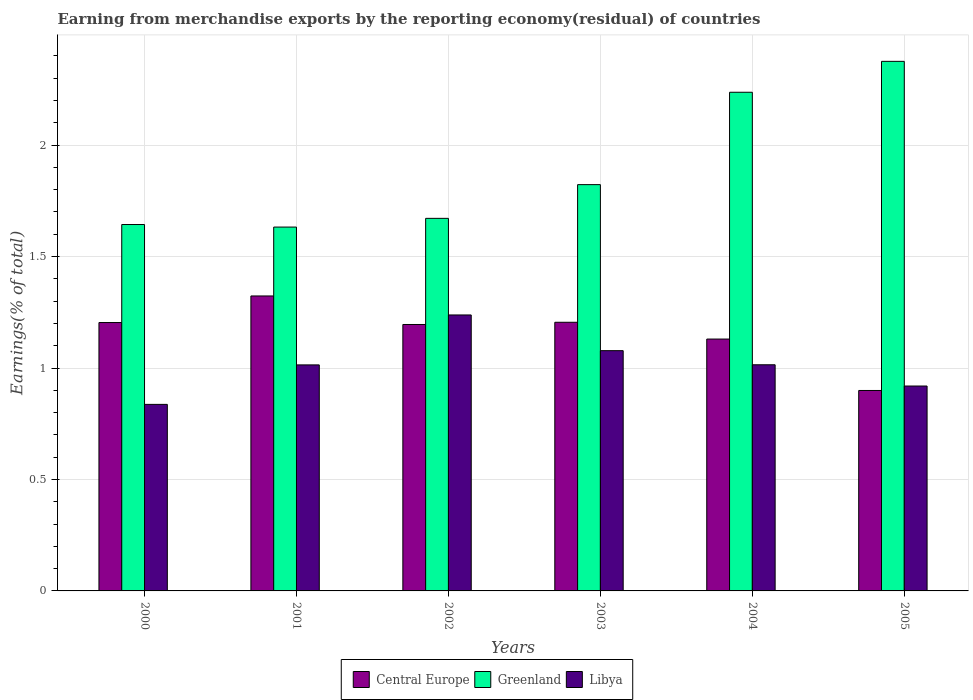Are the number of bars per tick equal to the number of legend labels?
Your answer should be very brief. Yes. How many bars are there on the 3rd tick from the left?
Your answer should be compact. 3. What is the label of the 1st group of bars from the left?
Provide a succinct answer. 2000. In how many cases, is the number of bars for a given year not equal to the number of legend labels?
Ensure brevity in your answer.  0. What is the percentage of amount earned from merchandise exports in Libya in 2005?
Provide a short and direct response. 0.92. Across all years, what is the maximum percentage of amount earned from merchandise exports in Greenland?
Ensure brevity in your answer.  2.38. Across all years, what is the minimum percentage of amount earned from merchandise exports in Libya?
Your answer should be compact. 0.84. What is the total percentage of amount earned from merchandise exports in Central Europe in the graph?
Provide a succinct answer. 6.96. What is the difference between the percentage of amount earned from merchandise exports in Greenland in 2000 and that in 2004?
Your answer should be compact. -0.59. What is the difference between the percentage of amount earned from merchandise exports in Central Europe in 2005 and the percentage of amount earned from merchandise exports in Libya in 2001?
Your answer should be compact. -0.11. What is the average percentage of amount earned from merchandise exports in Central Europe per year?
Provide a short and direct response. 1.16. In the year 2005, what is the difference between the percentage of amount earned from merchandise exports in Greenland and percentage of amount earned from merchandise exports in Libya?
Provide a succinct answer. 1.46. In how many years, is the percentage of amount earned from merchandise exports in Libya greater than 0.30000000000000004 %?
Keep it short and to the point. 6. What is the ratio of the percentage of amount earned from merchandise exports in Central Europe in 2000 to that in 2002?
Offer a terse response. 1.01. Is the percentage of amount earned from merchandise exports in Central Europe in 2000 less than that in 2005?
Offer a very short reply. No. Is the difference between the percentage of amount earned from merchandise exports in Greenland in 2003 and 2004 greater than the difference between the percentage of amount earned from merchandise exports in Libya in 2003 and 2004?
Offer a terse response. No. What is the difference between the highest and the second highest percentage of amount earned from merchandise exports in Greenland?
Your response must be concise. 0.14. What is the difference between the highest and the lowest percentage of amount earned from merchandise exports in Libya?
Your answer should be very brief. 0.4. In how many years, is the percentage of amount earned from merchandise exports in Libya greater than the average percentage of amount earned from merchandise exports in Libya taken over all years?
Your answer should be very brief. 2. What does the 1st bar from the left in 2003 represents?
Offer a very short reply. Central Europe. What does the 3rd bar from the right in 2005 represents?
Your answer should be compact. Central Europe. Are the values on the major ticks of Y-axis written in scientific E-notation?
Offer a terse response. No. Does the graph contain any zero values?
Offer a terse response. No. What is the title of the graph?
Ensure brevity in your answer.  Earning from merchandise exports by the reporting economy(residual) of countries. Does "Australia" appear as one of the legend labels in the graph?
Provide a succinct answer. No. What is the label or title of the X-axis?
Ensure brevity in your answer.  Years. What is the label or title of the Y-axis?
Keep it short and to the point. Earnings(% of total). What is the Earnings(% of total) in Central Europe in 2000?
Make the answer very short. 1.2. What is the Earnings(% of total) of Greenland in 2000?
Keep it short and to the point. 1.64. What is the Earnings(% of total) of Libya in 2000?
Ensure brevity in your answer.  0.84. What is the Earnings(% of total) of Central Europe in 2001?
Give a very brief answer. 1.32. What is the Earnings(% of total) in Greenland in 2001?
Offer a terse response. 1.63. What is the Earnings(% of total) in Libya in 2001?
Your answer should be compact. 1.01. What is the Earnings(% of total) of Central Europe in 2002?
Give a very brief answer. 1.2. What is the Earnings(% of total) of Greenland in 2002?
Offer a very short reply. 1.67. What is the Earnings(% of total) of Libya in 2002?
Ensure brevity in your answer.  1.24. What is the Earnings(% of total) in Central Europe in 2003?
Keep it short and to the point. 1.21. What is the Earnings(% of total) of Greenland in 2003?
Your response must be concise. 1.82. What is the Earnings(% of total) in Libya in 2003?
Keep it short and to the point. 1.08. What is the Earnings(% of total) in Central Europe in 2004?
Ensure brevity in your answer.  1.13. What is the Earnings(% of total) of Greenland in 2004?
Provide a short and direct response. 2.24. What is the Earnings(% of total) of Libya in 2004?
Provide a succinct answer. 1.01. What is the Earnings(% of total) in Central Europe in 2005?
Provide a short and direct response. 0.9. What is the Earnings(% of total) in Greenland in 2005?
Give a very brief answer. 2.38. What is the Earnings(% of total) of Libya in 2005?
Your answer should be compact. 0.92. Across all years, what is the maximum Earnings(% of total) of Central Europe?
Make the answer very short. 1.32. Across all years, what is the maximum Earnings(% of total) in Greenland?
Your answer should be very brief. 2.38. Across all years, what is the maximum Earnings(% of total) in Libya?
Keep it short and to the point. 1.24. Across all years, what is the minimum Earnings(% of total) in Central Europe?
Ensure brevity in your answer.  0.9. Across all years, what is the minimum Earnings(% of total) in Greenland?
Ensure brevity in your answer.  1.63. Across all years, what is the minimum Earnings(% of total) of Libya?
Provide a short and direct response. 0.84. What is the total Earnings(% of total) of Central Europe in the graph?
Provide a succinct answer. 6.96. What is the total Earnings(% of total) in Greenland in the graph?
Your answer should be very brief. 11.38. What is the total Earnings(% of total) of Libya in the graph?
Your answer should be compact. 6.1. What is the difference between the Earnings(% of total) of Central Europe in 2000 and that in 2001?
Offer a very short reply. -0.12. What is the difference between the Earnings(% of total) in Greenland in 2000 and that in 2001?
Offer a very short reply. 0.01. What is the difference between the Earnings(% of total) of Libya in 2000 and that in 2001?
Offer a terse response. -0.18. What is the difference between the Earnings(% of total) in Central Europe in 2000 and that in 2002?
Provide a succinct answer. 0.01. What is the difference between the Earnings(% of total) in Greenland in 2000 and that in 2002?
Give a very brief answer. -0.03. What is the difference between the Earnings(% of total) in Libya in 2000 and that in 2002?
Offer a terse response. -0.4. What is the difference between the Earnings(% of total) of Central Europe in 2000 and that in 2003?
Provide a short and direct response. -0. What is the difference between the Earnings(% of total) of Greenland in 2000 and that in 2003?
Keep it short and to the point. -0.18. What is the difference between the Earnings(% of total) of Libya in 2000 and that in 2003?
Your response must be concise. -0.24. What is the difference between the Earnings(% of total) of Central Europe in 2000 and that in 2004?
Your response must be concise. 0.07. What is the difference between the Earnings(% of total) in Greenland in 2000 and that in 2004?
Your answer should be compact. -0.59. What is the difference between the Earnings(% of total) of Libya in 2000 and that in 2004?
Your response must be concise. -0.18. What is the difference between the Earnings(% of total) in Central Europe in 2000 and that in 2005?
Give a very brief answer. 0.3. What is the difference between the Earnings(% of total) of Greenland in 2000 and that in 2005?
Your answer should be compact. -0.73. What is the difference between the Earnings(% of total) of Libya in 2000 and that in 2005?
Your response must be concise. -0.08. What is the difference between the Earnings(% of total) of Central Europe in 2001 and that in 2002?
Your response must be concise. 0.13. What is the difference between the Earnings(% of total) in Greenland in 2001 and that in 2002?
Give a very brief answer. -0.04. What is the difference between the Earnings(% of total) of Libya in 2001 and that in 2002?
Offer a terse response. -0.22. What is the difference between the Earnings(% of total) of Central Europe in 2001 and that in 2003?
Keep it short and to the point. 0.12. What is the difference between the Earnings(% of total) in Greenland in 2001 and that in 2003?
Keep it short and to the point. -0.19. What is the difference between the Earnings(% of total) in Libya in 2001 and that in 2003?
Your answer should be compact. -0.06. What is the difference between the Earnings(% of total) in Central Europe in 2001 and that in 2004?
Your answer should be very brief. 0.19. What is the difference between the Earnings(% of total) of Greenland in 2001 and that in 2004?
Provide a short and direct response. -0.6. What is the difference between the Earnings(% of total) in Libya in 2001 and that in 2004?
Your answer should be compact. -0. What is the difference between the Earnings(% of total) of Central Europe in 2001 and that in 2005?
Make the answer very short. 0.42. What is the difference between the Earnings(% of total) in Greenland in 2001 and that in 2005?
Make the answer very short. -0.74. What is the difference between the Earnings(% of total) of Libya in 2001 and that in 2005?
Offer a terse response. 0.09. What is the difference between the Earnings(% of total) of Central Europe in 2002 and that in 2003?
Your response must be concise. -0.01. What is the difference between the Earnings(% of total) of Greenland in 2002 and that in 2003?
Your response must be concise. -0.15. What is the difference between the Earnings(% of total) in Libya in 2002 and that in 2003?
Offer a terse response. 0.16. What is the difference between the Earnings(% of total) in Central Europe in 2002 and that in 2004?
Your answer should be compact. 0.07. What is the difference between the Earnings(% of total) in Greenland in 2002 and that in 2004?
Offer a terse response. -0.57. What is the difference between the Earnings(% of total) in Libya in 2002 and that in 2004?
Give a very brief answer. 0.22. What is the difference between the Earnings(% of total) of Central Europe in 2002 and that in 2005?
Your response must be concise. 0.3. What is the difference between the Earnings(% of total) of Greenland in 2002 and that in 2005?
Keep it short and to the point. -0.7. What is the difference between the Earnings(% of total) in Libya in 2002 and that in 2005?
Ensure brevity in your answer.  0.32. What is the difference between the Earnings(% of total) in Central Europe in 2003 and that in 2004?
Offer a very short reply. 0.08. What is the difference between the Earnings(% of total) of Greenland in 2003 and that in 2004?
Offer a terse response. -0.41. What is the difference between the Earnings(% of total) of Libya in 2003 and that in 2004?
Provide a succinct answer. 0.06. What is the difference between the Earnings(% of total) of Central Europe in 2003 and that in 2005?
Offer a terse response. 0.31. What is the difference between the Earnings(% of total) of Greenland in 2003 and that in 2005?
Provide a succinct answer. -0.55. What is the difference between the Earnings(% of total) in Libya in 2003 and that in 2005?
Ensure brevity in your answer.  0.16. What is the difference between the Earnings(% of total) in Central Europe in 2004 and that in 2005?
Your response must be concise. 0.23. What is the difference between the Earnings(% of total) in Greenland in 2004 and that in 2005?
Your answer should be very brief. -0.14. What is the difference between the Earnings(% of total) of Libya in 2004 and that in 2005?
Your answer should be very brief. 0.1. What is the difference between the Earnings(% of total) of Central Europe in 2000 and the Earnings(% of total) of Greenland in 2001?
Give a very brief answer. -0.43. What is the difference between the Earnings(% of total) in Central Europe in 2000 and the Earnings(% of total) in Libya in 2001?
Offer a very short reply. 0.19. What is the difference between the Earnings(% of total) in Greenland in 2000 and the Earnings(% of total) in Libya in 2001?
Offer a very short reply. 0.63. What is the difference between the Earnings(% of total) in Central Europe in 2000 and the Earnings(% of total) in Greenland in 2002?
Provide a succinct answer. -0.47. What is the difference between the Earnings(% of total) in Central Europe in 2000 and the Earnings(% of total) in Libya in 2002?
Your answer should be very brief. -0.03. What is the difference between the Earnings(% of total) in Greenland in 2000 and the Earnings(% of total) in Libya in 2002?
Your answer should be compact. 0.41. What is the difference between the Earnings(% of total) of Central Europe in 2000 and the Earnings(% of total) of Greenland in 2003?
Give a very brief answer. -0.62. What is the difference between the Earnings(% of total) of Central Europe in 2000 and the Earnings(% of total) of Libya in 2003?
Your answer should be compact. 0.13. What is the difference between the Earnings(% of total) in Greenland in 2000 and the Earnings(% of total) in Libya in 2003?
Ensure brevity in your answer.  0.57. What is the difference between the Earnings(% of total) of Central Europe in 2000 and the Earnings(% of total) of Greenland in 2004?
Your response must be concise. -1.03. What is the difference between the Earnings(% of total) in Central Europe in 2000 and the Earnings(% of total) in Libya in 2004?
Keep it short and to the point. 0.19. What is the difference between the Earnings(% of total) in Greenland in 2000 and the Earnings(% of total) in Libya in 2004?
Your answer should be compact. 0.63. What is the difference between the Earnings(% of total) of Central Europe in 2000 and the Earnings(% of total) of Greenland in 2005?
Offer a very short reply. -1.17. What is the difference between the Earnings(% of total) of Central Europe in 2000 and the Earnings(% of total) of Libya in 2005?
Offer a terse response. 0.28. What is the difference between the Earnings(% of total) of Greenland in 2000 and the Earnings(% of total) of Libya in 2005?
Provide a succinct answer. 0.72. What is the difference between the Earnings(% of total) in Central Europe in 2001 and the Earnings(% of total) in Greenland in 2002?
Make the answer very short. -0.35. What is the difference between the Earnings(% of total) in Central Europe in 2001 and the Earnings(% of total) in Libya in 2002?
Your answer should be very brief. 0.09. What is the difference between the Earnings(% of total) in Greenland in 2001 and the Earnings(% of total) in Libya in 2002?
Provide a succinct answer. 0.39. What is the difference between the Earnings(% of total) of Central Europe in 2001 and the Earnings(% of total) of Greenland in 2003?
Offer a terse response. -0.5. What is the difference between the Earnings(% of total) in Central Europe in 2001 and the Earnings(% of total) in Libya in 2003?
Provide a succinct answer. 0.25. What is the difference between the Earnings(% of total) of Greenland in 2001 and the Earnings(% of total) of Libya in 2003?
Your answer should be compact. 0.55. What is the difference between the Earnings(% of total) of Central Europe in 2001 and the Earnings(% of total) of Greenland in 2004?
Your response must be concise. -0.91. What is the difference between the Earnings(% of total) of Central Europe in 2001 and the Earnings(% of total) of Libya in 2004?
Offer a terse response. 0.31. What is the difference between the Earnings(% of total) of Greenland in 2001 and the Earnings(% of total) of Libya in 2004?
Make the answer very short. 0.62. What is the difference between the Earnings(% of total) of Central Europe in 2001 and the Earnings(% of total) of Greenland in 2005?
Your answer should be very brief. -1.05. What is the difference between the Earnings(% of total) in Central Europe in 2001 and the Earnings(% of total) in Libya in 2005?
Offer a very short reply. 0.4. What is the difference between the Earnings(% of total) in Greenland in 2001 and the Earnings(% of total) in Libya in 2005?
Your answer should be very brief. 0.71. What is the difference between the Earnings(% of total) of Central Europe in 2002 and the Earnings(% of total) of Greenland in 2003?
Offer a terse response. -0.63. What is the difference between the Earnings(% of total) of Central Europe in 2002 and the Earnings(% of total) of Libya in 2003?
Ensure brevity in your answer.  0.12. What is the difference between the Earnings(% of total) of Greenland in 2002 and the Earnings(% of total) of Libya in 2003?
Your answer should be compact. 0.59. What is the difference between the Earnings(% of total) of Central Europe in 2002 and the Earnings(% of total) of Greenland in 2004?
Make the answer very short. -1.04. What is the difference between the Earnings(% of total) in Central Europe in 2002 and the Earnings(% of total) in Libya in 2004?
Ensure brevity in your answer.  0.18. What is the difference between the Earnings(% of total) in Greenland in 2002 and the Earnings(% of total) in Libya in 2004?
Make the answer very short. 0.66. What is the difference between the Earnings(% of total) of Central Europe in 2002 and the Earnings(% of total) of Greenland in 2005?
Offer a very short reply. -1.18. What is the difference between the Earnings(% of total) of Central Europe in 2002 and the Earnings(% of total) of Libya in 2005?
Provide a succinct answer. 0.28. What is the difference between the Earnings(% of total) of Greenland in 2002 and the Earnings(% of total) of Libya in 2005?
Your answer should be very brief. 0.75. What is the difference between the Earnings(% of total) in Central Europe in 2003 and the Earnings(% of total) in Greenland in 2004?
Give a very brief answer. -1.03. What is the difference between the Earnings(% of total) in Central Europe in 2003 and the Earnings(% of total) in Libya in 2004?
Your response must be concise. 0.19. What is the difference between the Earnings(% of total) in Greenland in 2003 and the Earnings(% of total) in Libya in 2004?
Offer a very short reply. 0.81. What is the difference between the Earnings(% of total) of Central Europe in 2003 and the Earnings(% of total) of Greenland in 2005?
Your answer should be compact. -1.17. What is the difference between the Earnings(% of total) of Central Europe in 2003 and the Earnings(% of total) of Libya in 2005?
Provide a succinct answer. 0.29. What is the difference between the Earnings(% of total) in Greenland in 2003 and the Earnings(% of total) in Libya in 2005?
Provide a short and direct response. 0.9. What is the difference between the Earnings(% of total) in Central Europe in 2004 and the Earnings(% of total) in Greenland in 2005?
Your answer should be compact. -1.25. What is the difference between the Earnings(% of total) in Central Europe in 2004 and the Earnings(% of total) in Libya in 2005?
Provide a short and direct response. 0.21. What is the difference between the Earnings(% of total) of Greenland in 2004 and the Earnings(% of total) of Libya in 2005?
Offer a very short reply. 1.32. What is the average Earnings(% of total) of Central Europe per year?
Make the answer very short. 1.16. What is the average Earnings(% of total) of Greenland per year?
Ensure brevity in your answer.  1.9. What is the average Earnings(% of total) of Libya per year?
Offer a terse response. 1.02. In the year 2000, what is the difference between the Earnings(% of total) of Central Europe and Earnings(% of total) of Greenland?
Your answer should be compact. -0.44. In the year 2000, what is the difference between the Earnings(% of total) in Central Europe and Earnings(% of total) in Libya?
Provide a short and direct response. 0.37. In the year 2000, what is the difference between the Earnings(% of total) of Greenland and Earnings(% of total) of Libya?
Keep it short and to the point. 0.81. In the year 2001, what is the difference between the Earnings(% of total) in Central Europe and Earnings(% of total) in Greenland?
Keep it short and to the point. -0.31. In the year 2001, what is the difference between the Earnings(% of total) in Central Europe and Earnings(% of total) in Libya?
Keep it short and to the point. 0.31. In the year 2001, what is the difference between the Earnings(% of total) in Greenland and Earnings(% of total) in Libya?
Your answer should be very brief. 0.62. In the year 2002, what is the difference between the Earnings(% of total) in Central Europe and Earnings(% of total) in Greenland?
Your answer should be compact. -0.48. In the year 2002, what is the difference between the Earnings(% of total) in Central Europe and Earnings(% of total) in Libya?
Offer a terse response. -0.04. In the year 2002, what is the difference between the Earnings(% of total) of Greenland and Earnings(% of total) of Libya?
Provide a succinct answer. 0.43. In the year 2003, what is the difference between the Earnings(% of total) in Central Europe and Earnings(% of total) in Greenland?
Ensure brevity in your answer.  -0.62. In the year 2003, what is the difference between the Earnings(% of total) in Central Europe and Earnings(% of total) in Libya?
Give a very brief answer. 0.13. In the year 2003, what is the difference between the Earnings(% of total) of Greenland and Earnings(% of total) of Libya?
Your answer should be very brief. 0.74. In the year 2004, what is the difference between the Earnings(% of total) of Central Europe and Earnings(% of total) of Greenland?
Your answer should be compact. -1.11. In the year 2004, what is the difference between the Earnings(% of total) in Central Europe and Earnings(% of total) in Libya?
Provide a short and direct response. 0.12. In the year 2004, what is the difference between the Earnings(% of total) of Greenland and Earnings(% of total) of Libya?
Your answer should be compact. 1.22. In the year 2005, what is the difference between the Earnings(% of total) in Central Europe and Earnings(% of total) in Greenland?
Your response must be concise. -1.48. In the year 2005, what is the difference between the Earnings(% of total) in Central Europe and Earnings(% of total) in Libya?
Make the answer very short. -0.02. In the year 2005, what is the difference between the Earnings(% of total) of Greenland and Earnings(% of total) of Libya?
Your response must be concise. 1.46. What is the ratio of the Earnings(% of total) of Central Europe in 2000 to that in 2001?
Give a very brief answer. 0.91. What is the ratio of the Earnings(% of total) in Greenland in 2000 to that in 2001?
Keep it short and to the point. 1.01. What is the ratio of the Earnings(% of total) of Libya in 2000 to that in 2001?
Your response must be concise. 0.83. What is the ratio of the Earnings(% of total) in Central Europe in 2000 to that in 2002?
Your response must be concise. 1.01. What is the ratio of the Earnings(% of total) of Greenland in 2000 to that in 2002?
Offer a very short reply. 0.98. What is the ratio of the Earnings(% of total) of Libya in 2000 to that in 2002?
Keep it short and to the point. 0.68. What is the ratio of the Earnings(% of total) in Central Europe in 2000 to that in 2003?
Your answer should be very brief. 1. What is the ratio of the Earnings(% of total) in Greenland in 2000 to that in 2003?
Make the answer very short. 0.9. What is the ratio of the Earnings(% of total) in Libya in 2000 to that in 2003?
Keep it short and to the point. 0.78. What is the ratio of the Earnings(% of total) of Central Europe in 2000 to that in 2004?
Offer a very short reply. 1.07. What is the ratio of the Earnings(% of total) in Greenland in 2000 to that in 2004?
Ensure brevity in your answer.  0.73. What is the ratio of the Earnings(% of total) of Libya in 2000 to that in 2004?
Offer a very short reply. 0.82. What is the ratio of the Earnings(% of total) of Central Europe in 2000 to that in 2005?
Ensure brevity in your answer.  1.34. What is the ratio of the Earnings(% of total) of Greenland in 2000 to that in 2005?
Your response must be concise. 0.69. What is the ratio of the Earnings(% of total) of Libya in 2000 to that in 2005?
Your answer should be very brief. 0.91. What is the ratio of the Earnings(% of total) in Central Europe in 2001 to that in 2002?
Make the answer very short. 1.11. What is the ratio of the Earnings(% of total) in Greenland in 2001 to that in 2002?
Ensure brevity in your answer.  0.98. What is the ratio of the Earnings(% of total) in Libya in 2001 to that in 2002?
Provide a succinct answer. 0.82. What is the ratio of the Earnings(% of total) of Central Europe in 2001 to that in 2003?
Your response must be concise. 1.1. What is the ratio of the Earnings(% of total) of Greenland in 2001 to that in 2003?
Provide a succinct answer. 0.9. What is the ratio of the Earnings(% of total) of Libya in 2001 to that in 2003?
Make the answer very short. 0.94. What is the ratio of the Earnings(% of total) in Central Europe in 2001 to that in 2004?
Offer a terse response. 1.17. What is the ratio of the Earnings(% of total) of Greenland in 2001 to that in 2004?
Your response must be concise. 0.73. What is the ratio of the Earnings(% of total) of Central Europe in 2001 to that in 2005?
Keep it short and to the point. 1.47. What is the ratio of the Earnings(% of total) of Greenland in 2001 to that in 2005?
Provide a succinct answer. 0.69. What is the ratio of the Earnings(% of total) in Libya in 2001 to that in 2005?
Make the answer very short. 1.1. What is the ratio of the Earnings(% of total) of Central Europe in 2002 to that in 2003?
Make the answer very short. 0.99. What is the ratio of the Earnings(% of total) of Greenland in 2002 to that in 2003?
Give a very brief answer. 0.92. What is the ratio of the Earnings(% of total) in Libya in 2002 to that in 2003?
Offer a terse response. 1.15. What is the ratio of the Earnings(% of total) in Central Europe in 2002 to that in 2004?
Keep it short and to the point. 1.06. What is the ratio of the Earnings(% of total) in Greenland in 2002 to that in 2004?
Give a very brief answer. 0.75. What is the ratio of the Earnings(% of total) of Libya in 2002 to that in 2004?
Provide a short and direct response. 1.22. What is the ratio of the Earnings(% of total) in Central Europe in 2002 to that in 2005?
Your answer should be compact. 1.33. What is the ratio of the Earnings(% of total) in Greenland in 2002 to that in 2005?
Your response must be concise. 0.7. What is the ratio of the Earnings(% of total) in Libya in 2002 to that in 2005?
Your answer should be very brief. 1.35. What is the ratio of the Earnings(% of total) in Central Europe in 2003 to that in 2004?
Ensure brevity in your answer.  1.07. What is the ratio of the Earnings(% of total) of Greenland in 2003 to that in 2004?
Ensure brevity in your answer.  0.81. What is the ratio of the Earnings(% of total) of Libya in 2003 to that in 2004?
Your answer should be compact. 1.06. What is the ratio of the Earnings(% of total) in Central Europe in 2003 to that in 2005?
Offer a terse response. 1.34. What is the ratio of the Earnings(% of total) of Greenland in 2003 to that in 2005?
Keep it short and to the point. 0.77. What is the ratio of the Earnings(% of total) in Libya in 2003 to that in 2005?
Keep it short and to the point. 1.17. What is the ratio of the Earnings(% of total) of Central Europe in 2004 to that in 2005?
Ensure brevity in your answer.  1.26. What is the ratio of the Earnings(% of total) in Greenland in 2004 to that in 2005?
Keep it short and to the point. 0.94. What is the ratio of the Earnings(% of total) in Libya in 2004 to that in 2005?
Give a very brief answer. 1.1. What is the difference between the highest and the second highest Earnings(% of total) in Central Europe?
Offer a terse response. 0.12. What is the difference between the highest and the second highest Earnings(% of total) of Greenland?
Offer a terse response. 0.14. What is the difference between the highest and the second highest Earnings(% of total) of Libya?
Your response must be concise. 0.16. What is the difference between the highest and the lowest Earnings(% of total) of Central Europe?
Your response must be concise. 0.42. What is the difference between the highest and the lowest Earnings(% of total) in Greenland?
Your response must be concise. 0.74. What is the difference between the highest and the lowest Earnings(% of total) of Libya?
Your answer should be compact. 0.4. 